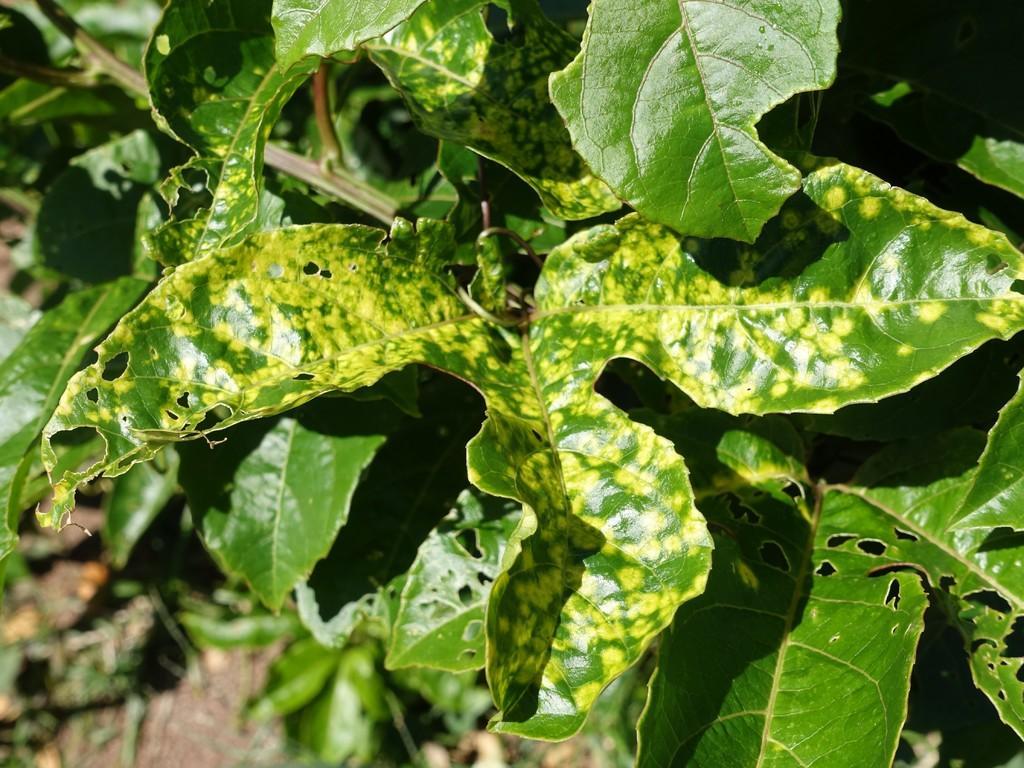Describe this image in one or two sentences. In this image I see number of leaves on the stems. 